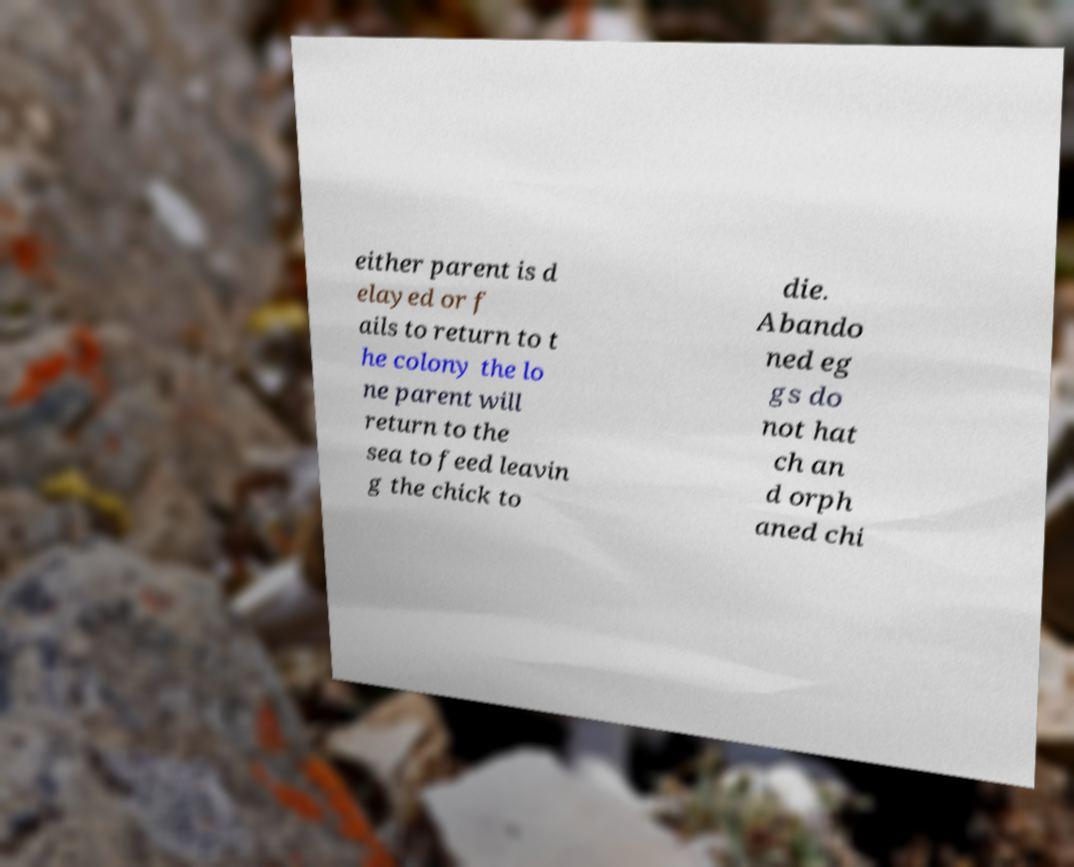I need the written content from this picture converted into text. Can you do that? either parent is d elayed or f ails to return to t he colony the lo ne parent will return to the sea to feed leavin g the chick to die. Abando ned eg gs do not hat ch an d orph aned chi 